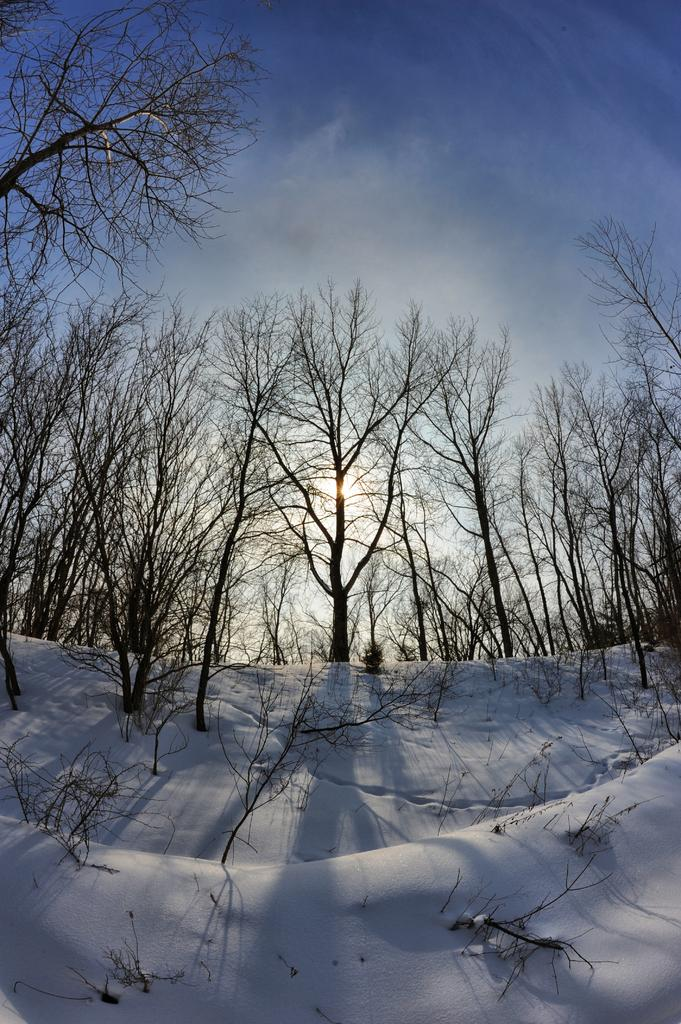What is the main feature of the image? There is a snow hill in the image. What can be found on the snow hill? There are plants and trees on the snow hill. What is the color of the sky in the background? The sky is blue in the background. Are there any weather conditions visible in the image? Yes, there are clouds in the sky. Where is the office located in the image? There is no office present in the image; it features a snow hill with plants and trees. How many pigs can be seen interacting with the plants on the snow hill? There are no pigs present in the image; it only features plants and trees on the snow hill. 